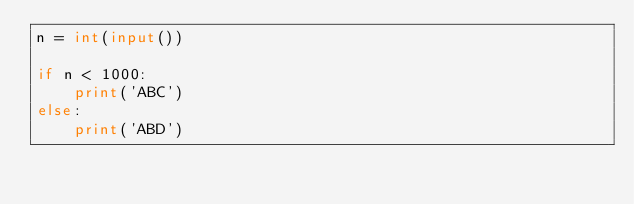Convert code to text. <code><loc_0><loc_0><loc_500><loc_500><_Python_>n = int(input())

if n < 1000:
    print('ABC')
else:
    print('ABD')</code> 